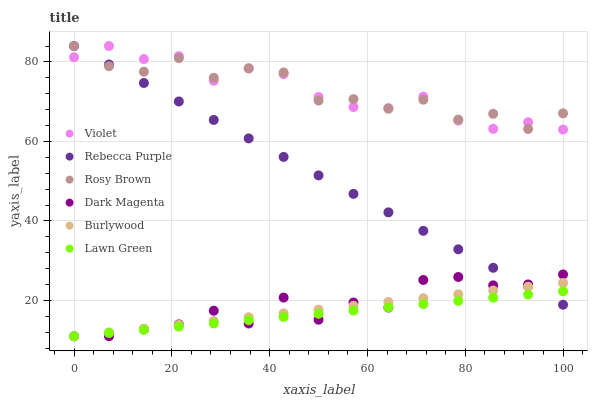Does Lawn Green have the minimum area under the curve?
Answer yes or no. Yes. Does Violet have the maximum area under the curve?
Answer yes or no. Yes. Does Dark Magenta have the minimum area under the curve?
Answer yes or no. No. Does Dark Magenta have the maximum area under the curve?
Answer yes or no. No. Is Burlywood the smoothest?
Answer yes or no. Yes. Is Rosy Brown the roughest?
Answer yes or no. Yes. Is Dark Magenta the smoothest?
Answer yes or no. No. Is Dark Magenta the roughest?
Answer yes or no. No. Does Lawn Green have the lowest value?
Answer yes or no. Yes. Does Rosy Brown have the lowest value?
Answer yes or no. No. Does Violet have the highest value?
Answer yes or no. Yes. Does Dark Magenta have the highest value?
Answer yes or no. No. Is Lawn Green less than Rosy Brown?
Answer yes or no. Yes. Is Rosy Brown greater than Lawn Green?
Answer yes or no. Yes. Does Rebecca Purple intersect Lawn Green?
Answer yes or no. Yes. Is Rebecca Purple less than Lawn Green?
Answer yes or no. No. Is Rebecca Purple greater than Lawn Green?
Answer yes or no. No. Does Lawn Green intersect Rosy Brown?
Answer yes or no. No. 